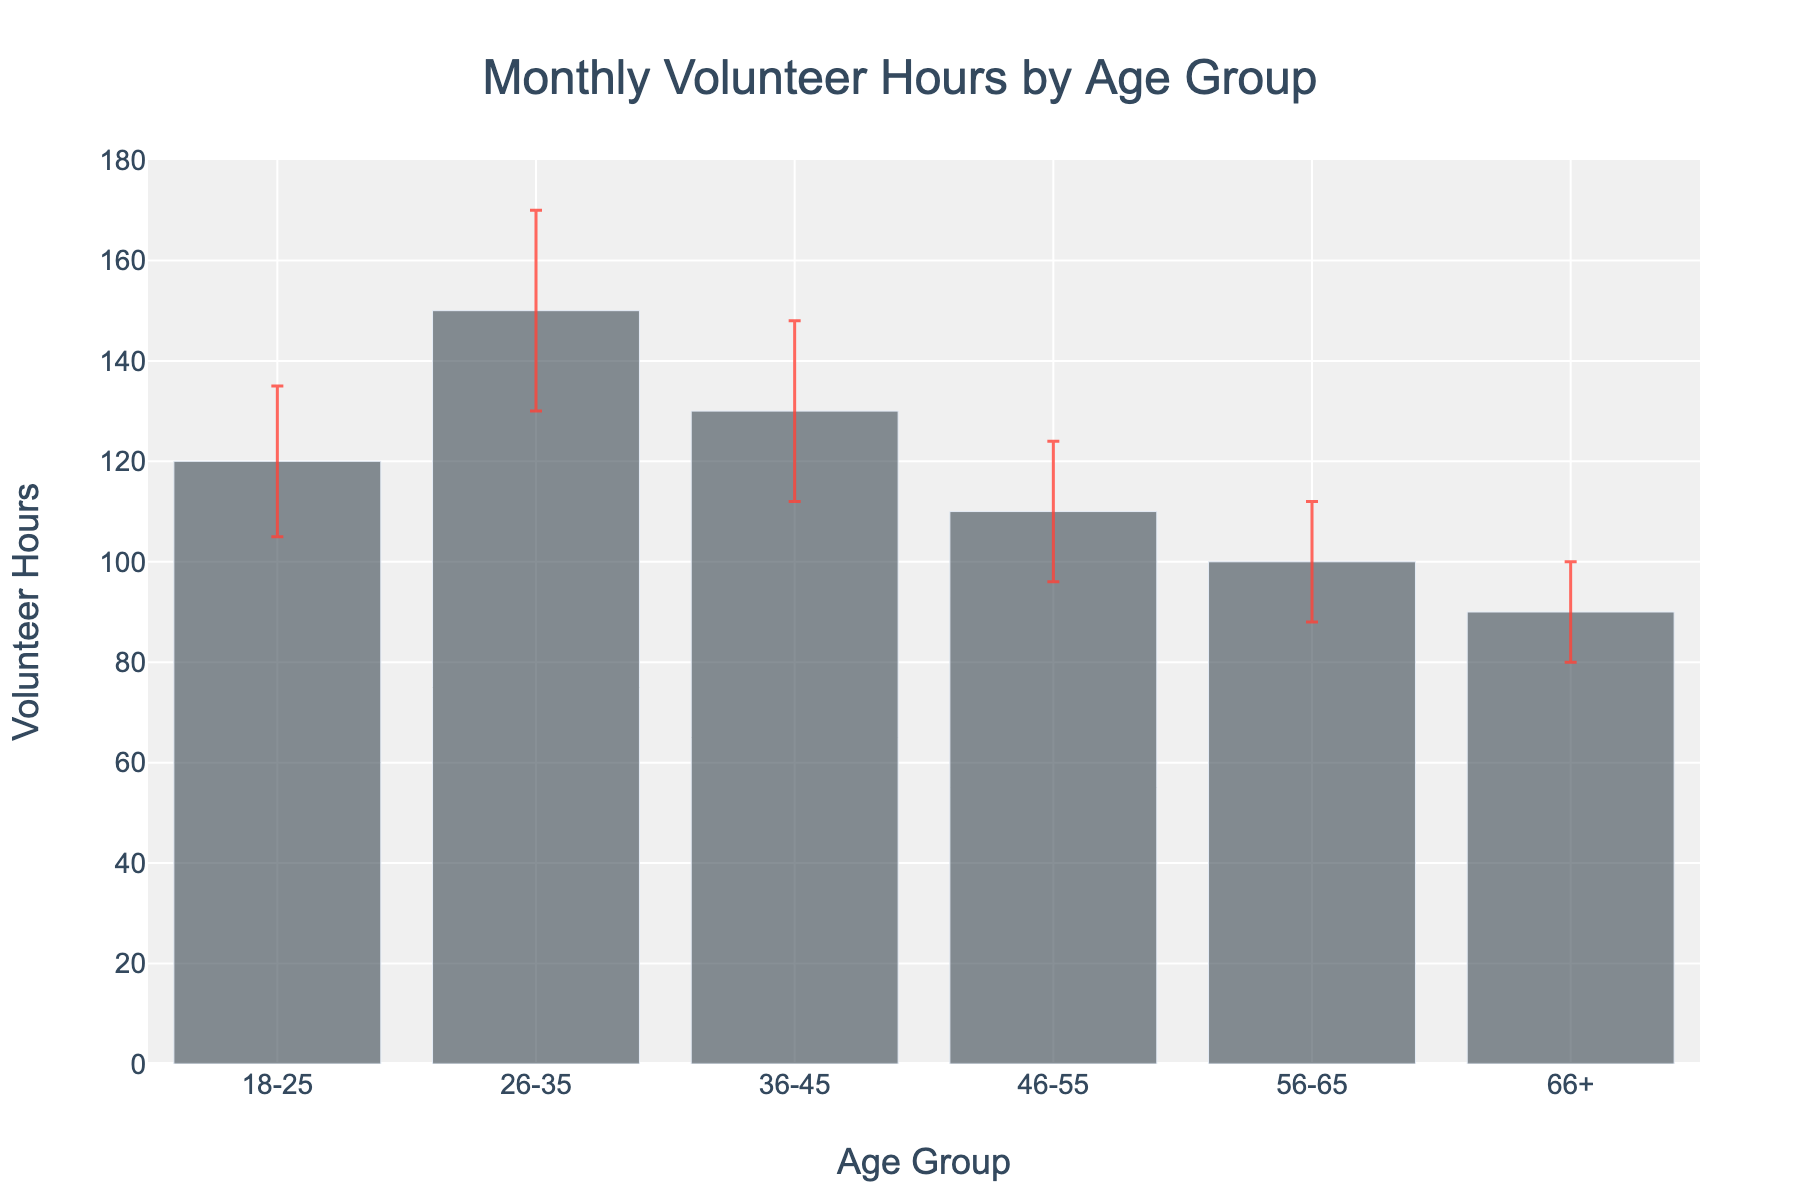what is the title of the chart? The title of a chart is typically found at the top and provides a summary of what the chart represents. Here, it says "Monthly Volunteer Hours by Age Group".
Answer: Monthly Volunteer Hours by Age Group Which age group contributed the highest number of volunteer hours? To find the age group with the highest number of volunteer hours, we look for the tallest bar in the chart. The bar representing the 26-35 age group is the tallest.
Answer: 26-35 What is the y-axis label for the chart? The y-axis label is located on the vertical axis of the chart; it indicates what the values on that axis represent. Here, the y-axis label is "Volunteer Hours".
Answer: Volunteer Hours What's the volunteer hours difference between the 18-25 and 66+ age groups? To find the difference, look at the heights of the bars for each age group. The 18-25 age group has 120 hours and the 66+ group has 90 hours. Subtract 90 from 120 (120 - 90).
Answer: 30 hours Which age group has the largest uncertainty in their volunteer hours? Uncertainty is represented by the length of the error bars. The age group with the longest error bar is 26-35, having a standard deviation of 20.
Answer: 26-35 What is the average number of volunteer hours across all age groups? To calculate the average, add the volunteer hours of all age groups and then divide by the number of groups. The sums are 120 + 150 + 130 + 110 + 100 + 90 = 700. There are 6 age groups, so 700/6.
Answer: About 116.67 hours Compare the volunteer hours contributed by the 36-45 age group to that of the 46-55 age group? Compare the heights of the two bars. The 36-45 age group has 130 hours, while the 46-55 age group has 110 hours. So, 130 is greater than 110.
Answer: 36-45 > 46-55 What is the total range of volunteer hours contributed across all age groups? To find the range, subtract the smallest value from the largest value. The smallest number of hours is 90 (66+ age group), and the largest is 150 (26-35 age group). So, 150 - 90.
Answer: 60 hours Estimate the possible highest and lowest volunteer hours reported by the 56-65 age group considering the error bars? The 56-65 age group has 100 volunteer hours with an error bar of 12. This means the range could be from 88 (100-12) to 112 (100+12).
Answer: 88 to 112 